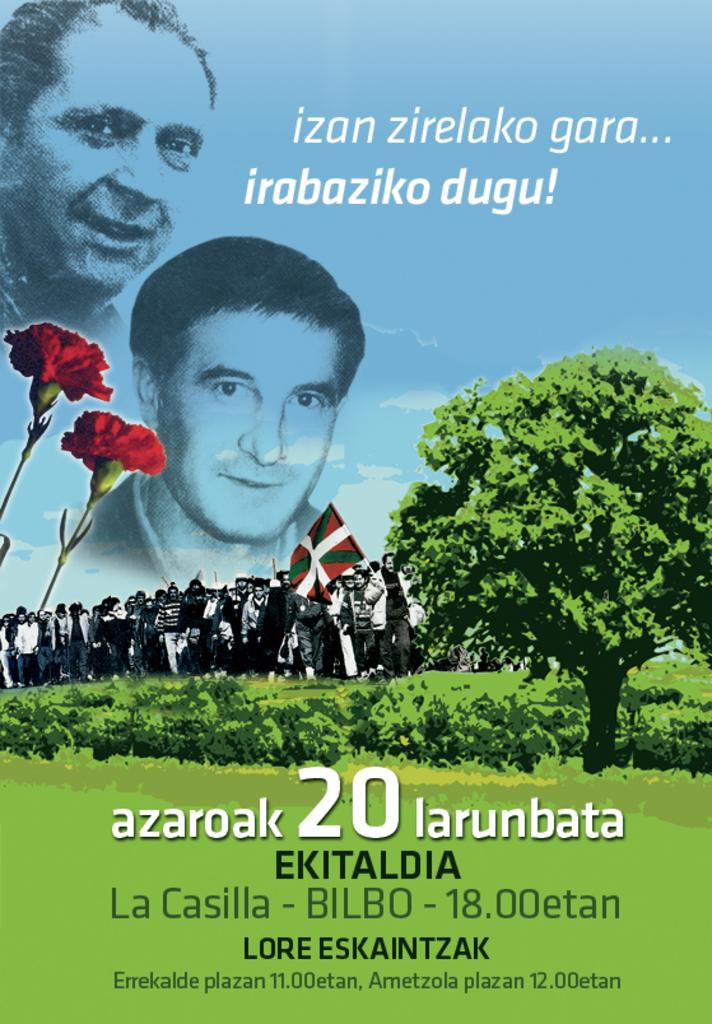<image>
Offer a succinct explanation of the picture presented. Poster that says "azaroak 20 larunbata" showing a man's face next to a tree. 